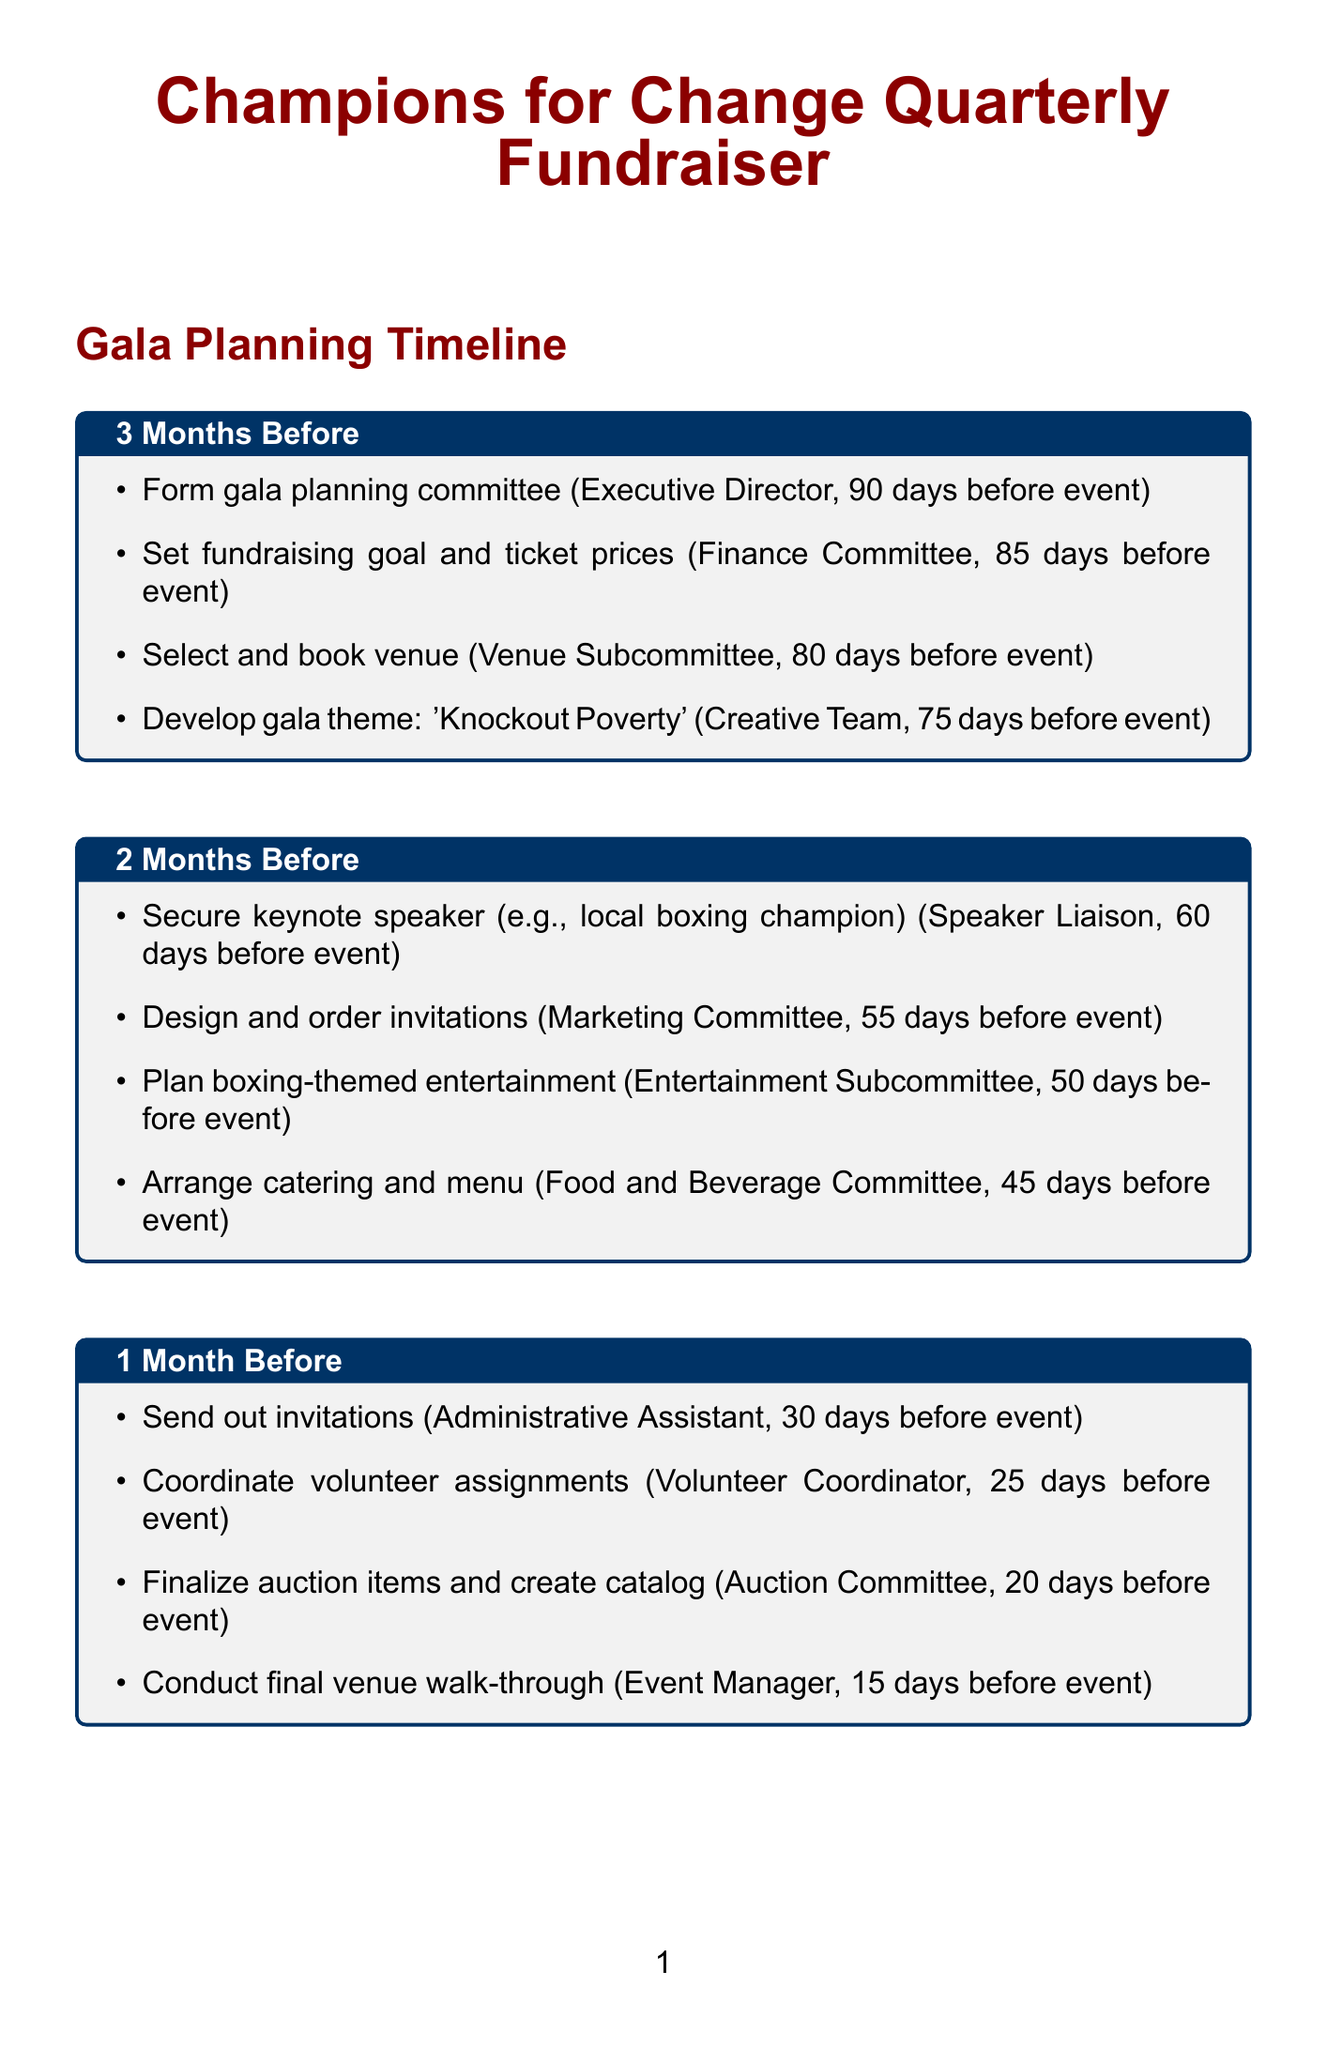What is the name of the gala? The gala is titled "Champions for Change Quarterly Fundraiser."
Answer: Champions for Change Quarterly Fundraiser Who is responsible for selecting and booking the venue? The Venue Subcommittee is tasked with selecting and booking the venue.
Answer: Venue Subcommittee When should the invitations be sent out? Invitations are to be sent out 30 days before the event.
Answer: 30 days before event What is the theme of the gala? The gala theme is "Knockout Poverty".
Answer: Knockout Poverty How long after the event should thank-you notes be sent? Thank-you notes should be sent within 1 week after the event.
Answer: Within 1 week after event Who coordinates volunteer assignments? The Volunteer Coordinator is responsible for coordinating volunteer assignments.
Answer: Volunteer Coordinator What phase includes securing a keynote speaker? This task is part of the "2 Months Before" phase of planning.
Answer: 2 Months Before How many weeks after the event is the post-event evaluation meeting scheduled? The evaluation meeting is scheduled within 3 weeks after the event.
Answer: Within 3 weeks after event What day is the final team briefing conducted? The final team briefing is conducted on the day of the event.
Answer: Day of event 